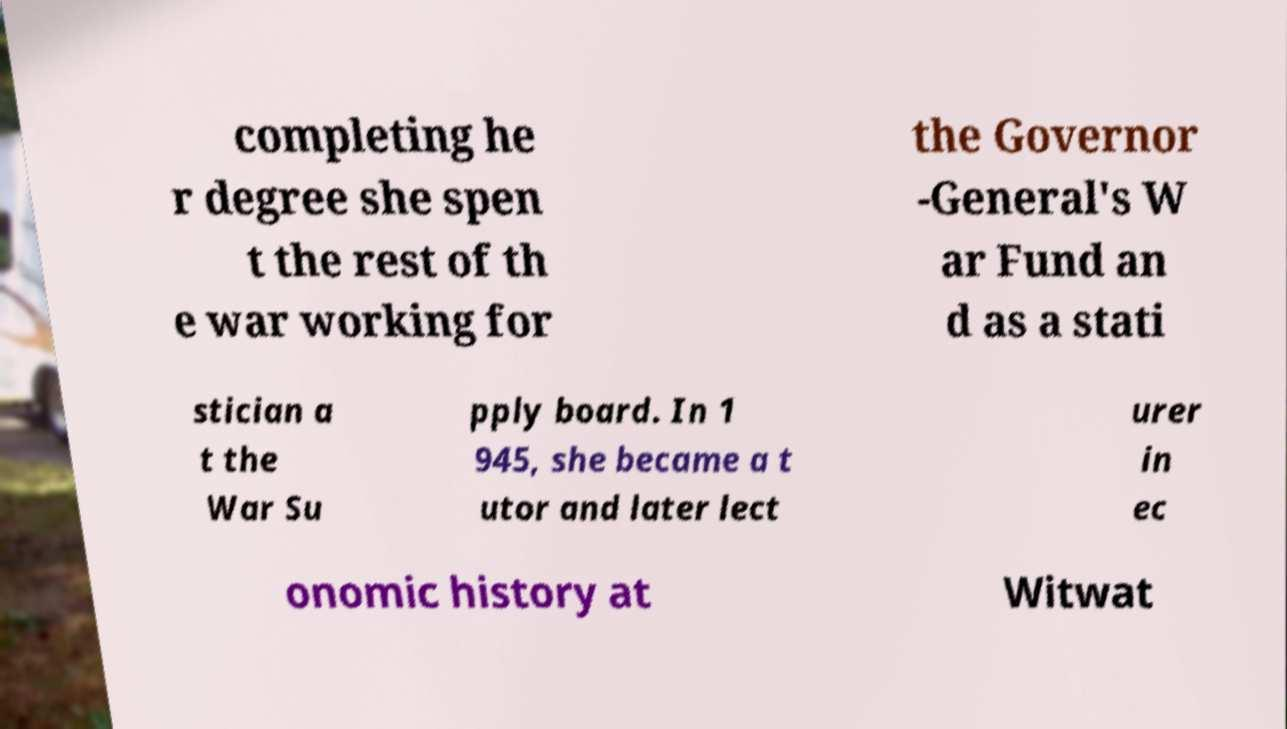There's text embedded in this image that I need extracted. Can you transcribe it verbatim? completing he r degree she spen t the rest of th e war working for the Governor -General's W ar Fund an d as a stati stician a t the War Su pply board. In 1 945, she became a t utor and later lect urer in ec onomic history at Witwat 